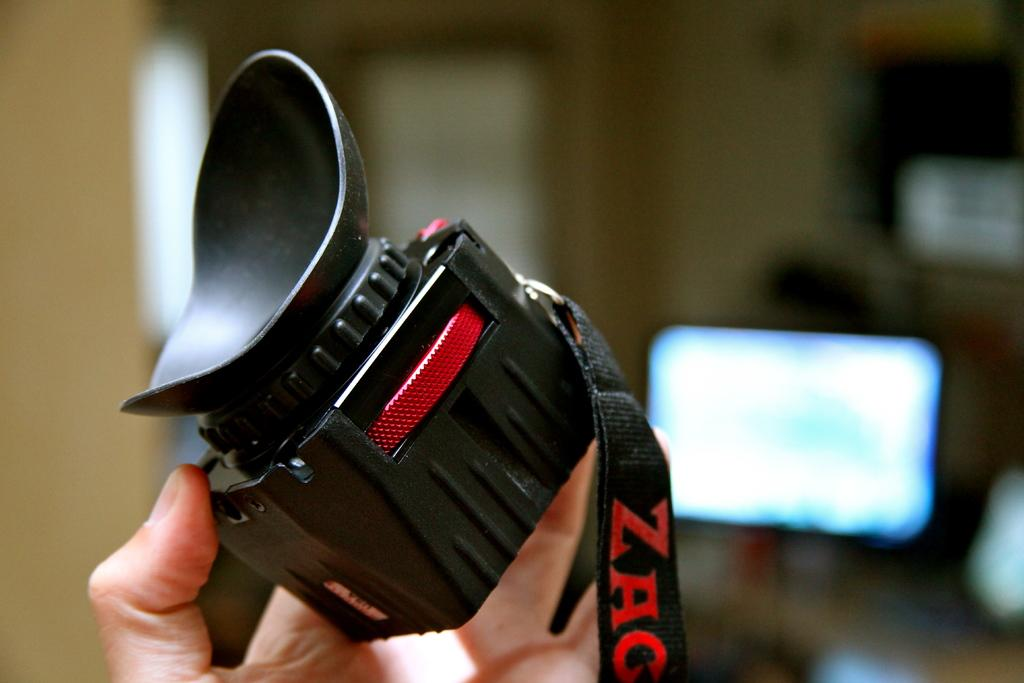What is the person's hand holding in the image? The person's hand is holding a camera in the image. What is the color of the camera? The camera is black in color. Is there any additional information about the camera's appearance? Yes, the camera has a black color tag. What feature of the camera is visible in the image? The camera has a screen. What type of behavior is the person's mouth exhibiting in the image? There is no information about the person's mouth or behavior in the image, as the focus is on the person's hand holding a camera. 